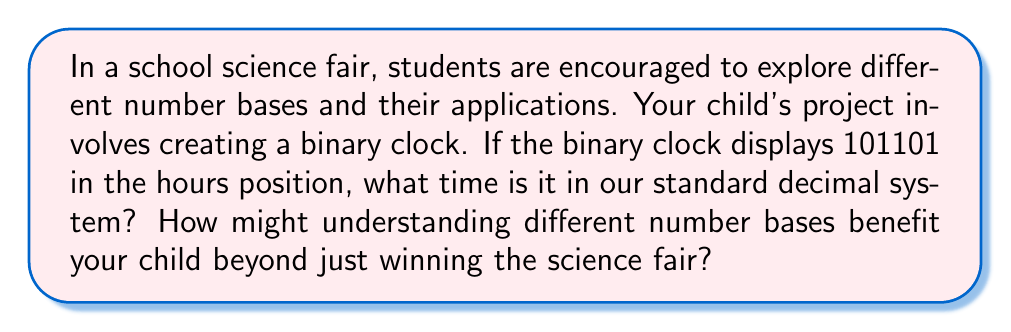Could you help me with this problem? Let's approach this step-by-step:

1) First, we need to convert the binary number 101101 to decimal. In binary, each digit represents a power of 2, starting from the rightmost digit:

   $$101101_2 = 1\cdot2^5 + 0\cdot2^4 + 1\cdot2^3 + 1\cdot2^2 + 0\cdot2^1 + 1\cdot2^0$$

2) Let's calculate each term:
   $$1\cdot2^5 = 1\cdot32 = 32$$
   $$0\cdot2^4 = 0\cdot16 = 0$$
   $$1\cdot2^3 = 1\cdot8 = 8$$
   $$1\cdot2^2 = 1\cdot4 = 4$$
   $$0\cdot2^1 = 0\cdot2 = 0$$
   $$1\cdot2^0 = 1\cdot1 = 1$$

3) Now, we sum these values:
   $$32 + 0 + 8 + 4 + 0 + 1 = 45$$

4) Therefore, 101101 in binary is equal to 45 in decimal.

5) However, most clocks use a 12-hour system. To convert 45 to a 12-hour clock, we can use the modulo operation:

   $$45 \bmod 12 = 9$$

This means the time shown on the binary clock is 9:00.

Regarding the benefits of understanding different number bases:

1) It enhances problem-solving skills and mathematical thinking.
2) It provides a foundation for understanding computer science and digital systems.
3) It encourages creativity in approaching mathematical concepts.
4) It can boost confidence in tackling unfamiliar mathematical ideas.
5) It promotes a broader understanding of mathematics beyond just arithmetic.

These benefits go beyond winning a science fair. They contribute to your child's overall cognitive development and prepare them for future academic and real-world challenges. The focus should be on the learning process and personal growth rather than just the competition outcome.
Answer: The binary clock is showing 9:00. 